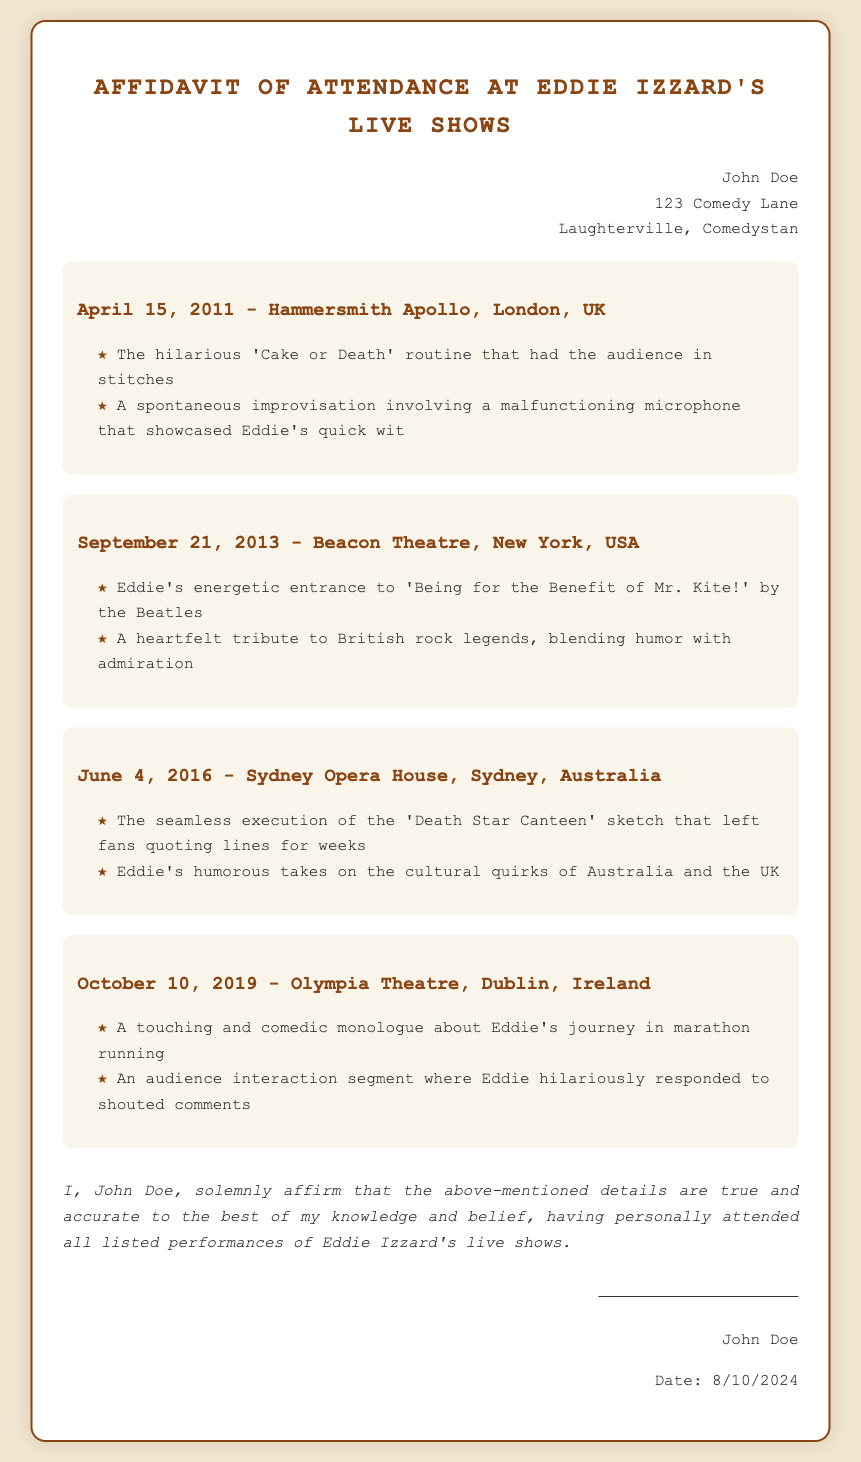What is the name of the attendee? The name of the attendee is presented at the top of the document in the attendee info section.
Answer: John Doe What date was the show at Hammersmith Apollo? The date of the event is listed under the event title for Hammersmith Apollo.
Answer: April 15, 2011 What sketch was performed during the Sydney Opera House show? The specific sketch is mentioned in the event details for the Sydney Opera House performance.
Answer: Death Star Canteen How many events are listed in the affidavit? This can be determined by counting the number of event sections in the document.
Answer: 4 Which venue hosted Eddie Izzard's show on October 10, 2019? The venue for that date is specified in the corresponding event section.
Answer: Olympia Theatre What memorable moment is mentioned for the New York show? The moment is detailed in the items listed under the event for the Beacon Theatre.
Answer: A heartfelt tribute to British rock legends What is stated about the accurateness of details in the affidavit? The statement is included in the last paragraph of the document, emphasizing the truth of the details.
Answer: True and accurate What is the location of the event on June 4, 2016? The location of the event is stated in the title for the corresponding event section.
Answer: Sydney Opera House 